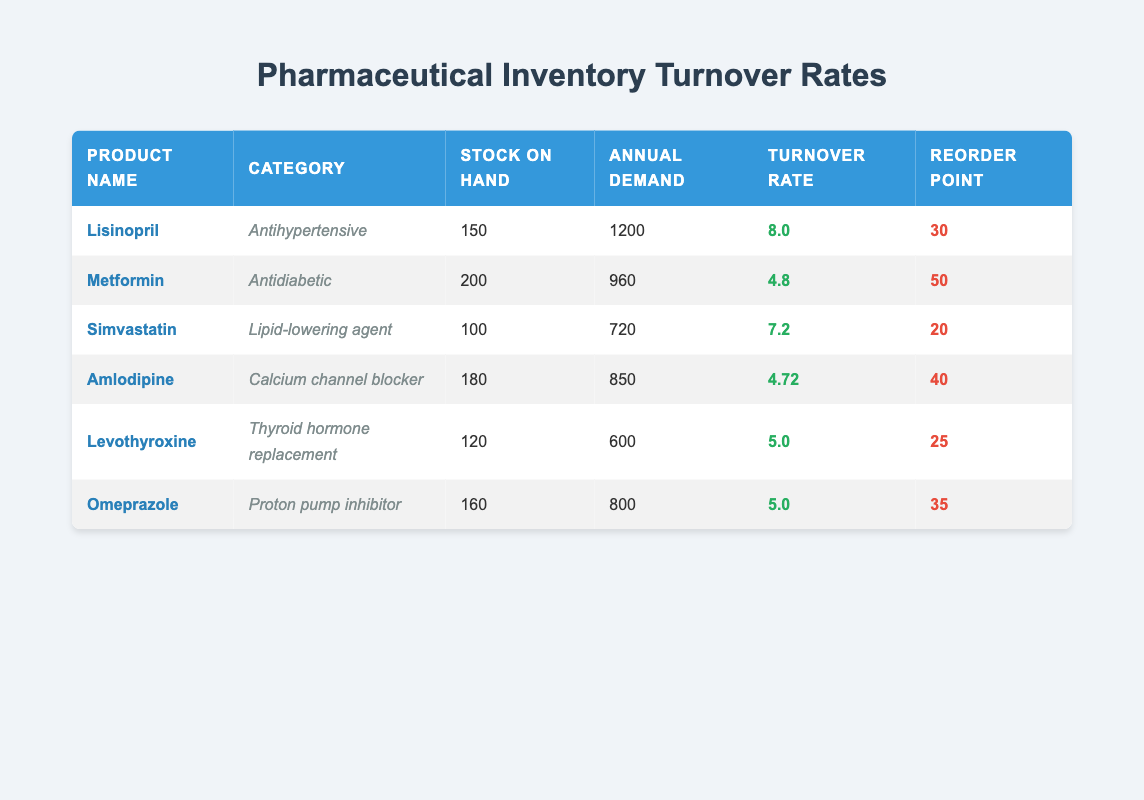What is the stock on hand for Lisinopril? The table directly lists the stock on hand for each product. For Lisinopril, it is specified as 150.
Answer: 150 Which product has the highest turnover rate? By looking at the turnover rates listed in the table, Lisinopril has the highest rate at 8.0.
Answer: Lisinopril What is the average annual demand for all products? To calculate the average, sum the annual demands: (1200 + 960 + 720 + 850 + 600 + 800) = 4130. Then divide by the number of products (6): 4130 / 6 = 688.33.
Answer: 688.33 Is the reorder point for Omeprazole higher than that for Simvastatin? The reorder point for Omeprazole is 35, while for Simvastatin it is 20. Since 35 is greater than 20, the statement is true.
Answer: Yes How many products have a stock on hand greater than 150? By reviewing the stock on hand values in the table—Lisinopril (150), Metformin (200), Amlodipine (180), Omeprazole (160)—only Metformin and Amlodipine are greater than 150. Thus, there are two of them.
Answer: 2 What is the difference in stock on hand between Levothyroxine and Amlodipine? Levothyroxine has 120 in stock while Amlodipine has 180. The difference is calculated as 180 - 120 = 60.
Answer: 60 Which product has a turnover rate lower than 5.0? The table shows Metformin (4.8) and Amlodipine (4.72) both have turnover rates lower than 5.0.
Answer: Metformin, Amlodipine Is the product category for Simvastatin classified as an Antidiabetic? Simvastatin is listed under the category of Lipid-lowering agent, not Antidiabetic. Therefore, the statement is false.
Answer: No What is the total annual demand for Antihypertensive drugs? Only Lisinopril is listed in the Antihypertensive category with an annual demand of 1200. So, the total demand is simply 1200.
Answer: 1200 